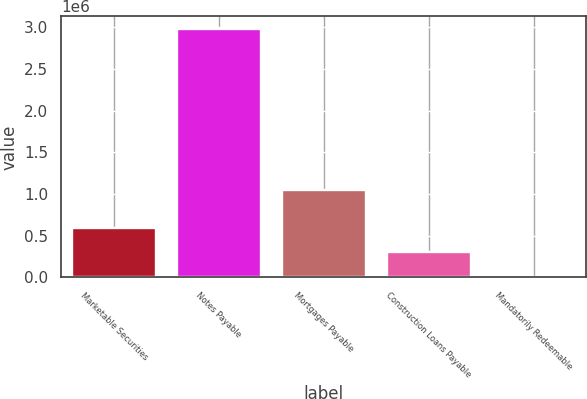Convert chart to OTSL. <chart><loc_0><loc_0><loc_500><loc_500><bar_chart><fcel>Marketable Securities<fcel>Notes Payable<fcel>Mortgages Payable<fcel>Construction Loans Payable<fcel>Mandatorily Redeemable<nl><fcel>598642<fcel>2.98242e+06<fcel>1.04631e+06<fcel>300669<fcel>2697<nl></chart> 